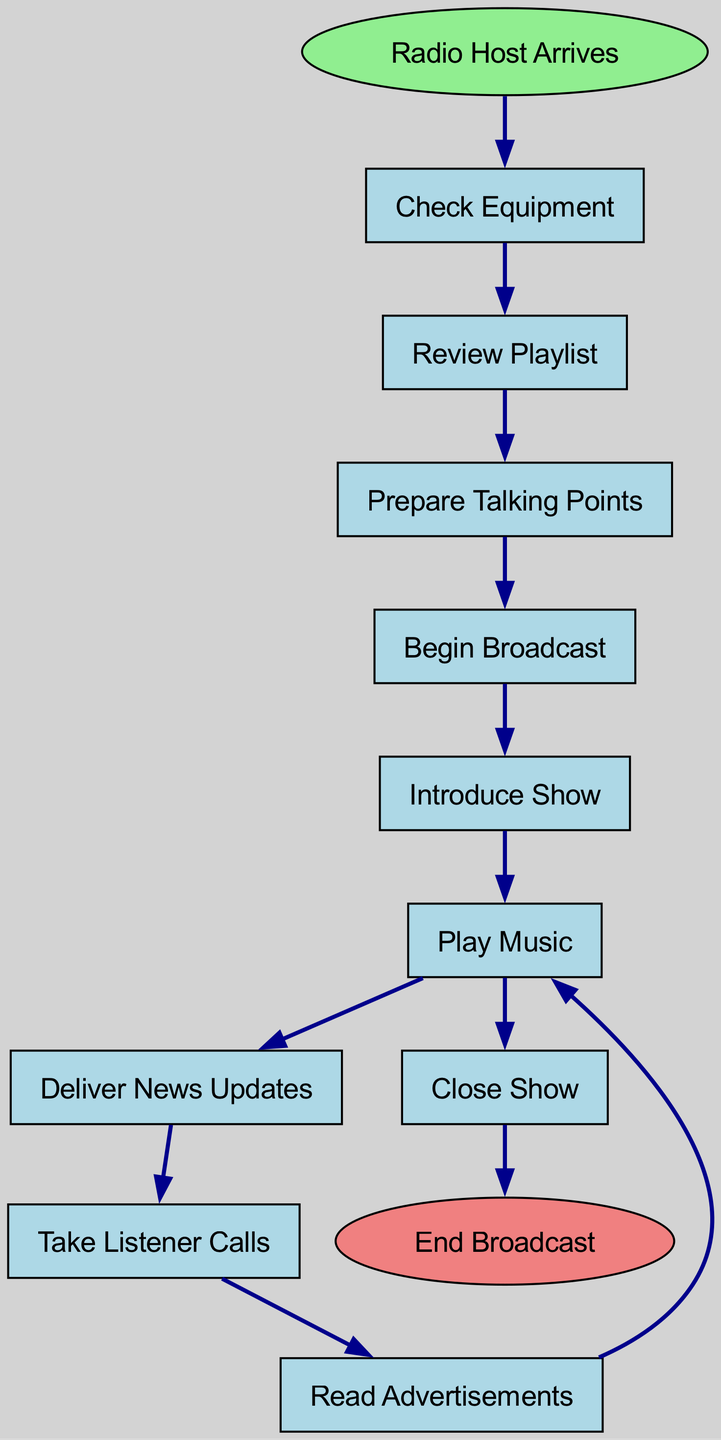What is the starting node of the broadcasting process? The starting node of the broadcasting process is labeled "Radio Host Arrives," indicating the initiation point of the flow chart.
Answer: Radio Host Arrives What is the last action before ending the broadcast? The last action before reaching the end of the broadcast is "Play Music," which leads directly to the end node labeled "End Broadcast."
Answer: Play Music How many nodes are present in the diagram? The diagram includes a total of 10 nodes, which encompass both the actions and start/end nodes, as counted from the list provided.
Answer: 10 What action follows "Prepare Talking Points"? The action that follows "Prepare Talking Points" is "Begin Broadcast," as indicated by the directed flow from one to the next in the diagram.
Answer: Begin Broadcast What action leads to "Take Listener Calls"? The action that leads to "Take Listener Calls" is "Deliver News Updates," connecting these actions sequentially through the flow chart.
Answer: Deliver News Updates What is the relationship between "Read Advertisements" and "Play Music"? "Read Advertisements" is connected to "Play Music" in two ways: it is the preceding action before returning to "Play Music," and it also reflects the looping nature of the broadcast process.
Answer: Precedes and Follows How many edges connect the nodes in the diagram? There are a total of 10 edges connecting the nodes, as each connection represents a transition from one action to the next in the flow of the process.
Answer: 10 Which two actions are connected directly before the "Close Show"? The two actions connected directly before reaching "Close Show" are "Play Music" leading to the conclusion of the show, demonstrating the final engagement with the listeners.
Answer: Play Music, Close Show What is the initial step a radio host takes upon arrival? Upon arrival, the first step a radio host takes is to "Check Equipment," ensuring that all necessary tools and technology are functional before proceeding.
Answer: Check Equipment 